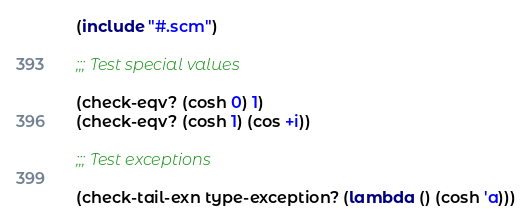Convert code to text. <code><loc_0><loc_0><loc_500><loc_500><_Scheme_>(include "#.scm")

;;; Test special values

(check-eqv? (cosh 0) 1)
(check-eqv? (cosh 1) (cos +i))

;;; Test exceptions

(check-tail-exn type-exception? (lambda () (cosh 'a)))

</code> 